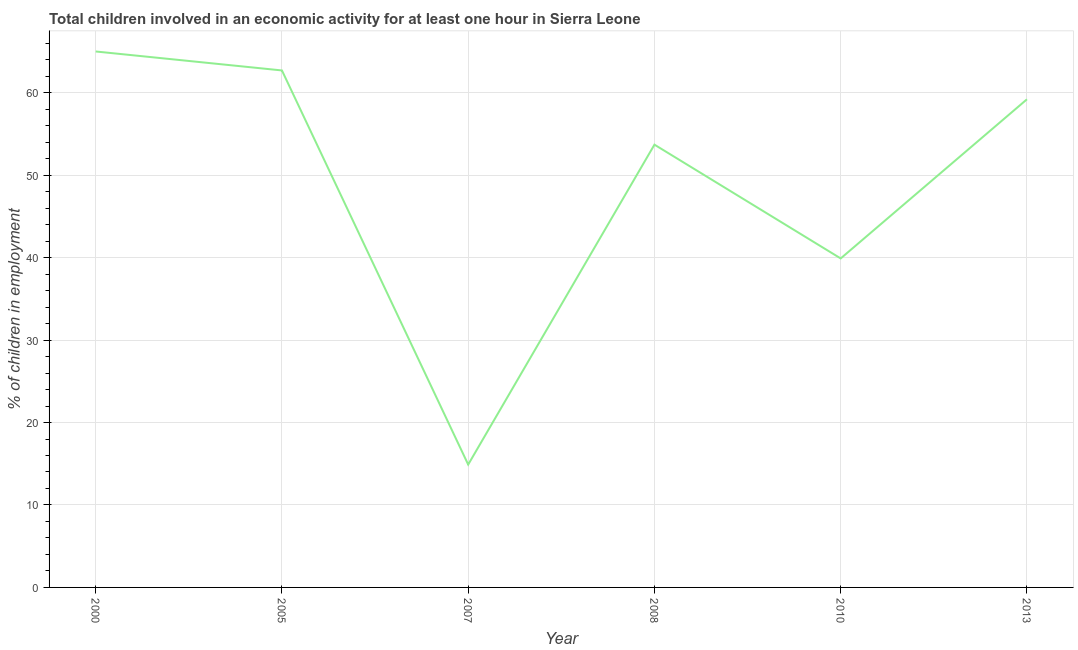In which year was the percentage of children in employment maximum?
Your answer should be compact. 2000. What is the sum of the percentage of children in employment?
Your answer should be very brief. 295.4. What is the average percentage of children in employment per year?
Keep it short and to the point. 49.23. What is the median percentage of children in employment?
Your response must be concise. 56.45. In how many years, is the percentage of children in employment greater than 38 %?
Provide a short and direct response. 5. What is the ratio of the percentage of children in employment in 2007 to that in 2013?
Your answer should be compact. 0.25. Is the percentage of children in employment in 2000 less than that in 2010?
Give a very brief answer. No. Is the difference between the percentage of children in employment in 2010 and 2013 greater than the difference between any two years?
Your answer should be compact. No. What is the difference between the highest and the second highest percentage of children in employment?
Provide a succinct answer. 2.3. Is the sum of the percentage of children in employment in 2000 and 2005 greater than the maximum percentage of children in employment across all years?
Keep it short and to the point. Yes. What is the difference between the highest and the lowest percentage of children in employment?
Your response must be concise. 50.1. Does the percentage of children in employment monotonically increase over the years?
Your response must be concise. No. What is the difference between two consecutive major ticks on the Y-axis?
Your response must be concise. 10. Are the values on the major ticks of Y-axis written in scientific E-notation?
Provide a short and direct response. No. Does the graph contain grids?
Keep it short and to the point. Yes. What is the title of the graph?
Ensure brevity in your answer.  Total children involved in an economic activity for at least one hour in Sierra Leone. What is the label or title of the Y-axis?
Offer a terse response. % of children in employment. What is the % of children in employment in 2005?
Your answer should be very brief. 62.7. What is the % of children in employment of 2008?
Your answer should be very brief. 53.7. What is the % of children in employment in 2010?
Your answer should be very brief. 39.9. What is the % of children in employment in 2013?
Your response must be concise. 59.2. What is the difference between the % of children in employment in 2000 and 2005?
Your answer should be compact. 2.3. What is the difference between the % of children in employment in 2000 and 2007?
Offer a very short reply. 50.1. What is the difference between the % of children in employment in 2000 and 2008?
Make the answer very short. 11.3. What is the difference between the % of children in employment in 2000 and 2010?
Your answer should be very brief. 25.1. What is the difference between the % of children in employment in 2005 and 2007?
Your answer should be very brief. 47.8. What is the difference between the % of children in employment in 2005 and 2010?
Make the answer very short. 22.8. What is the difference between the % of children in employment in 2007 and 2008?
Your response must be concise. -38.8. What is the difference between the % of children in employment in 2007 and 2010?
Your response must be concise. -25. What is the difference between the % of children in employment in 2007 and 2013?
Your response must be concise. -44.3. What is the difference between the % of children in employment in 2010 and 2013?
Provide a short and direct response. -19.3. What is the ratio of the % of children in employment in 2000 to that in 2005?
Ensure brevity in your answer.  1.04. What is the ratio of the % of children in employment in 2000 to that in 2007?
Your answer should be very brief. 4.36. What is the ratio of the % of children in employment in 2000 to that in 2008?
Provide a succinct answer. 1.21. What is the ratio of the % of children in employment in 2000 to that in 2010?
Your response must be concise. 1.63. What is the ratio of the % of children in employment in 2000 to that in 2013?
Offer a terse response. 1.1. What is the ratio of the % of children in employment in 2005 to that in 2007?
Make the answer very short. 4.21. What is the ratio of the % of children in employment in 2005 to that in 2008?
Give a very brief answer. 1.17. What is the ratio of the % of children in employment in 2005 to that in 2010?
Ensure brevity in your answer.  1.57. What is the ratio of the % of children in employment in 2005 to that in 2013?
Your answer should be compact. 1.06. What is the ratio of the % of children in employment in 2007 to that in 2008?
Keep it short and to the point. 0.28. What is the ratio of the % of children in employment in 2007 to that in 2010?
Provide a succinct answer. 0.37. What is the ratio of the % of children in employment in 2007 to that in 2013?
Provide a short and direct response. 0.25. What is the ratio of the % of children in employment in 2008 to that in 2010?
Make the answer very short. 1.35. What is the ratio of the % of children in employment in 2008 to that in 2013?
Provide a short and direct response. 0.91. What is the ratio of the % of children in employment in 2010 to that in 2013?
Offer a very short reply. 0.67. 